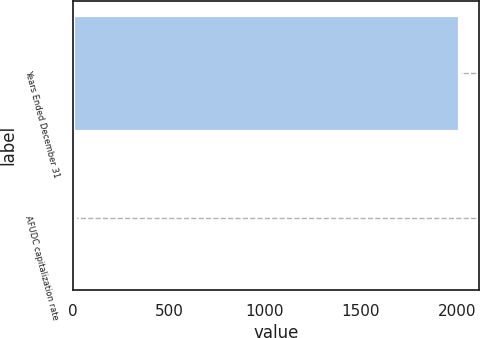<chart> <loc_0><loc_0><loc_500><loc_500><bar_chart><fcel>Years Ended December 31<fcel>AFUDC capitalization rate<nl><fcel>2014<fcel>7.2<nl></chart> 